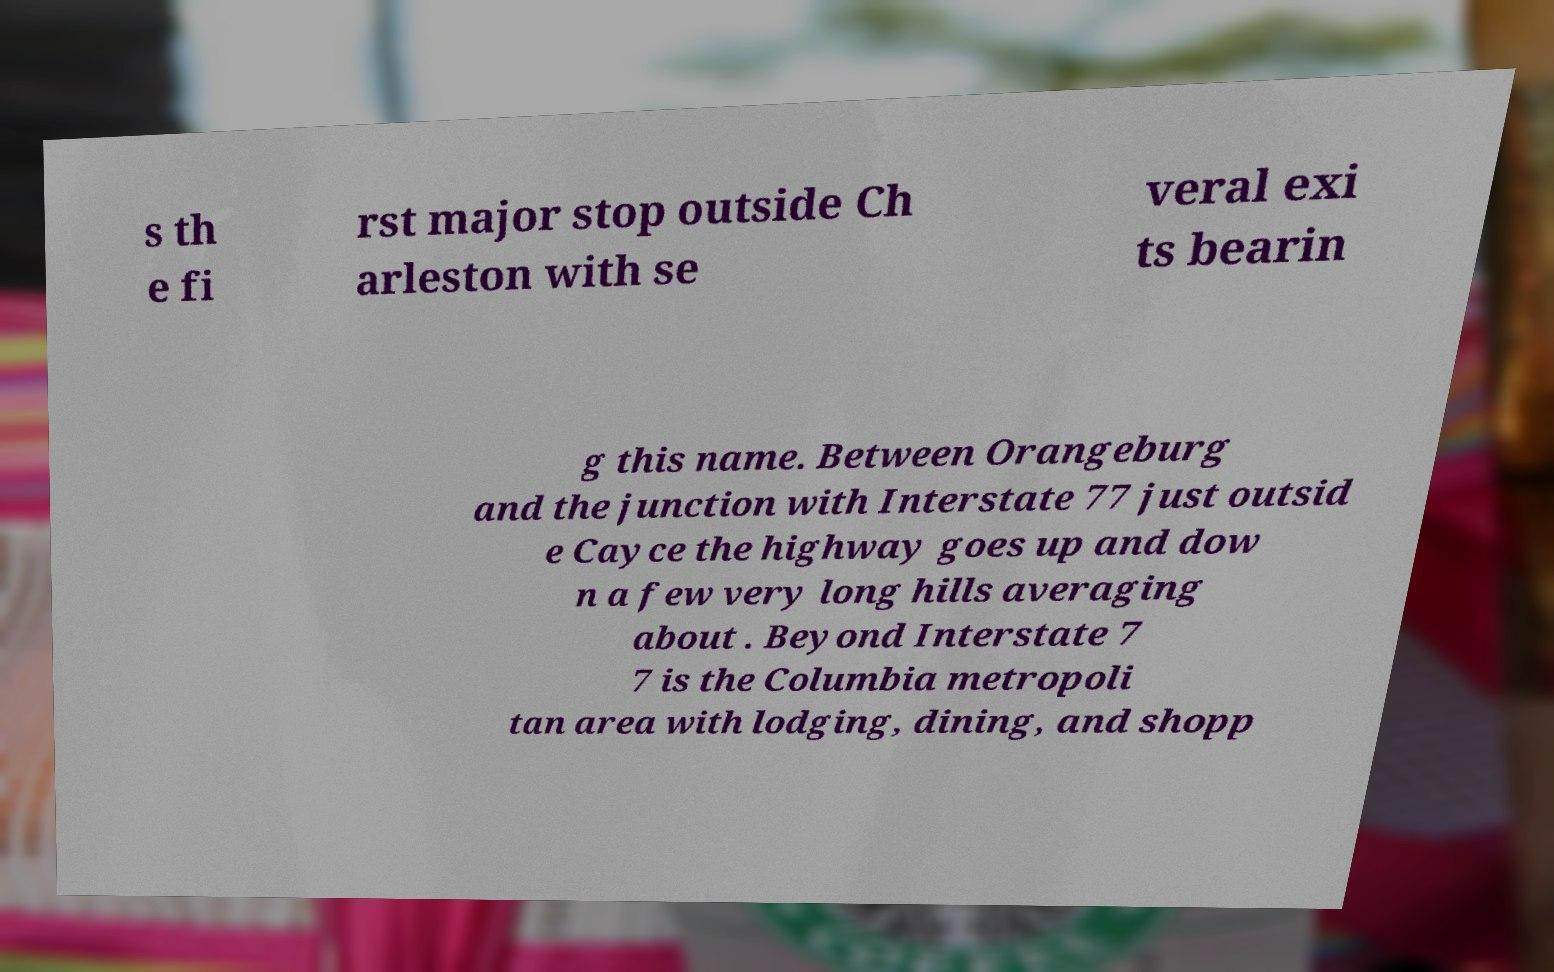Please identify and transcribe the text found in this image. s th e fi rst major stop outside Ch arleston with se veral exi ts bearin g this name. Between Orangeburg and the junction with Interstate 77 just outsid e Cayce the highway goes up and dow n a few very long hills averaging about . Beyond Interstate 7 7 is the Columbia metropoli tan area with lodging, dining, and shopp 